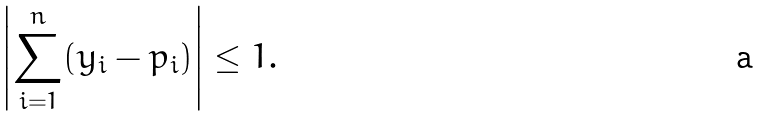Convert formula to latex. <formula><loc_0><loc_0><loc_500><loc_500>\left | \sum _ { i = 1 } ^ { n } ( y _ { i } - p _ { i } ) \right | \leq 1 .</formula> 